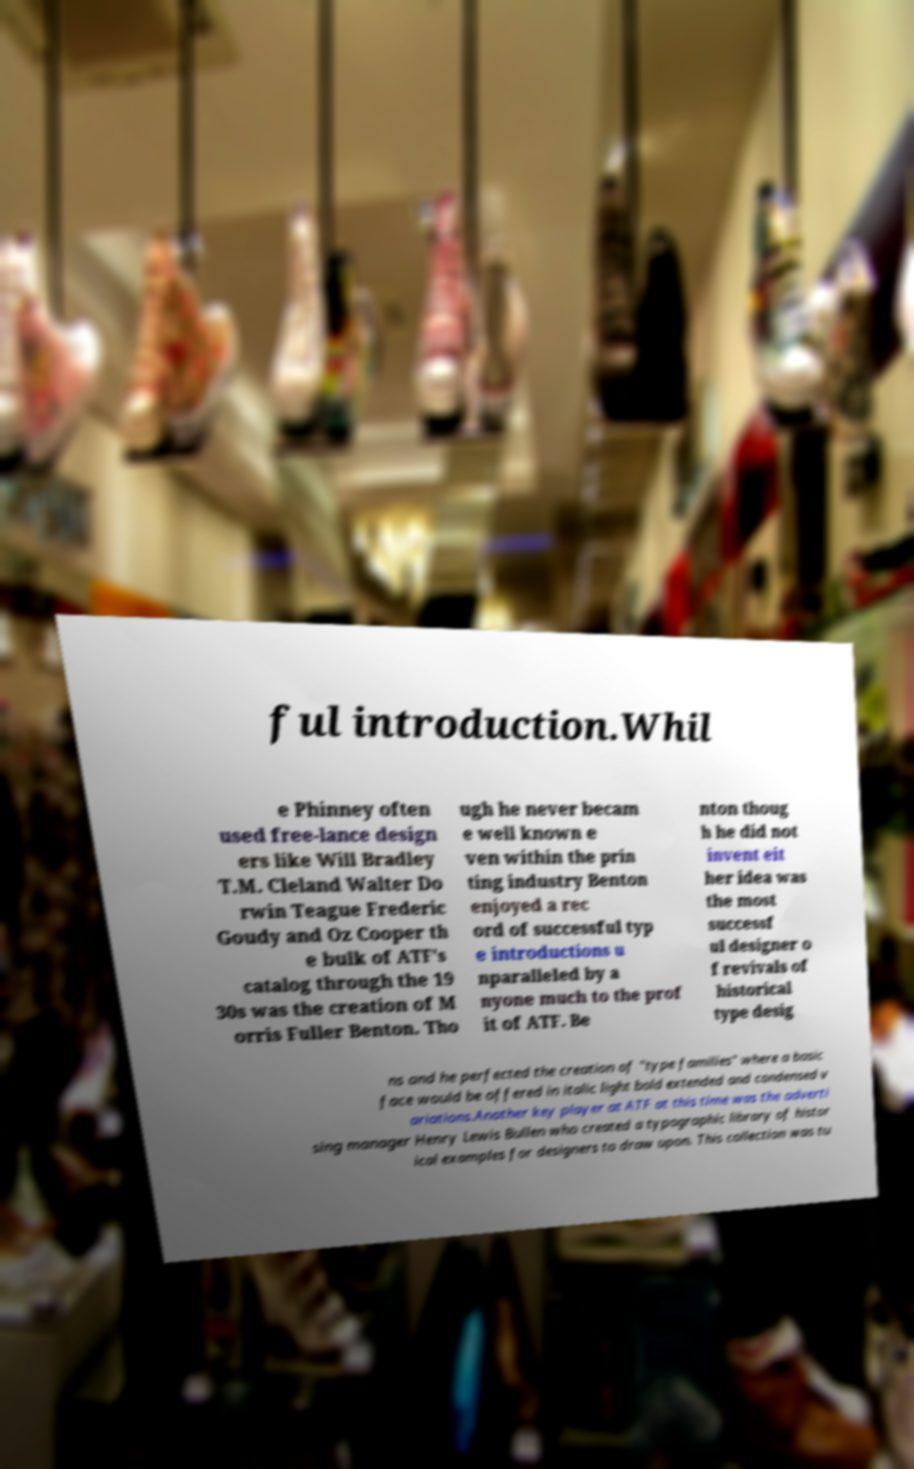Please read and relay the text visible in this image. What does it say? ful introduction.Whil e Phinney often used free-lance design ers like Will Bradley T.M. Cleland Walter Do rwin Teague Frederic Goudy and Oz Cooper th e bulk of ATF's catalog through the 19 30s was the creation of M orris Fuller Benton. Tho ugh he never becam e well known e ven within the prin ting industry Benton enjoyed a rec ord of successful typ e introductions u nparalleled by a nyone much to the prof it of ATF. Be nton thoug h he did not invent eit her idea was the most successf ul designer o f revivals of historical type desig ns and he perfected the creation of "type families" where a basic face would be offered in italic light bold extended and condensed v ariations.Another key player at ATF at this time was the adverti sing manager Henry Lewis Bullen who created a typographic library of histor ical examples for designers to draw upon. This collection was tu 